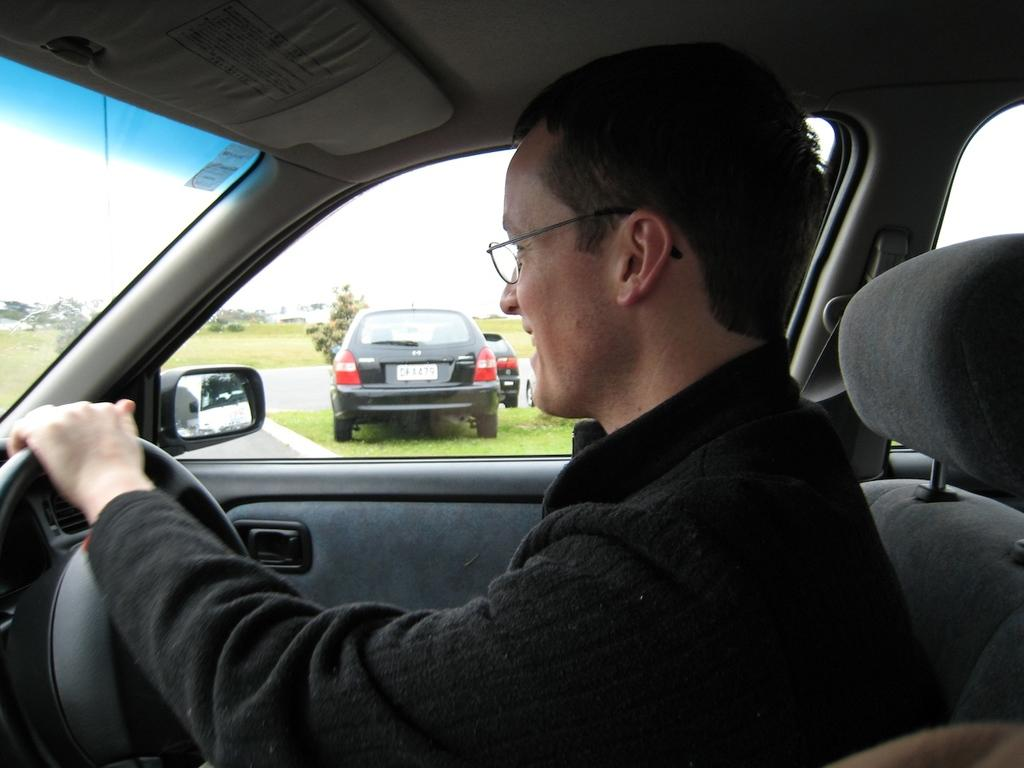Where was the image taken? The image was taken inside a car. Who is operating the car? There is a person driving the car. What is the location of the car? The car is on the road. What can be seen in the background of the image? There are two black color cars and trees visible in the background. What type of cream is being used to clean the beast in the image? There is no beast or cream present in the image; it was taken inside a car with a person driving. 